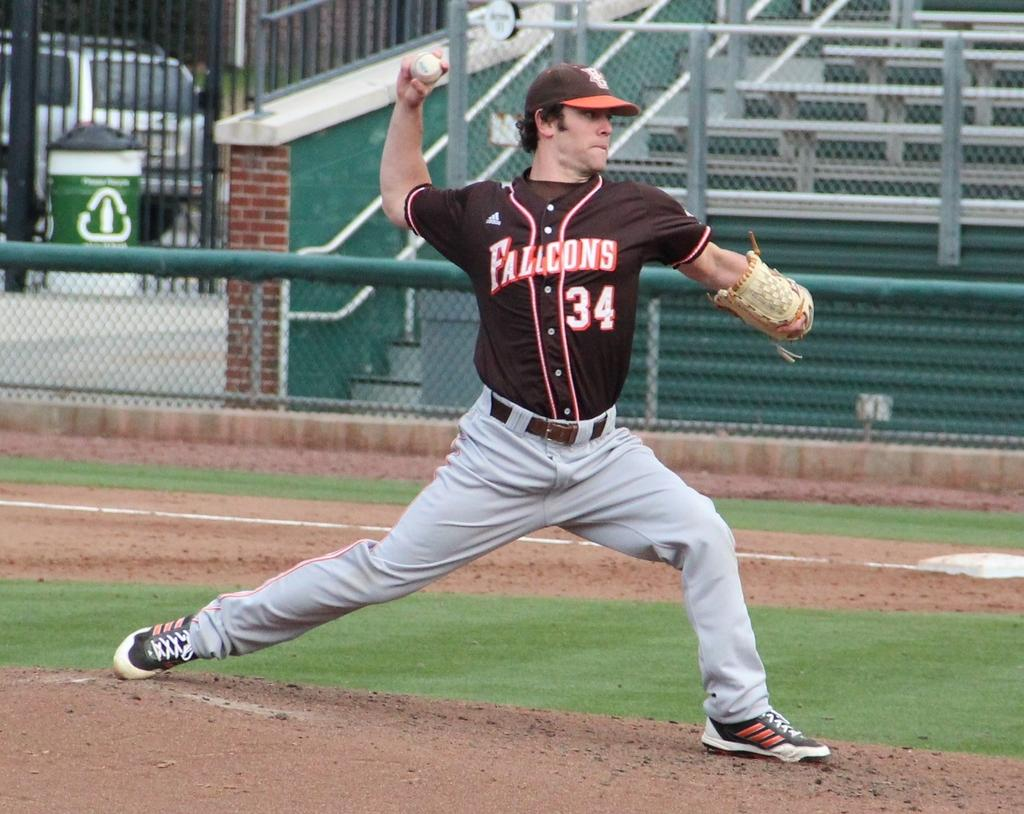Who is present in the image? There is a man in the image. What is the man doing in the image? The man is throwing a ball. What type of surface is at the bottom of the image? There is grass at the bottom of the image. What can be seen in the middle of the image? There is fencing in the middle of the image. What is visible in the background of the image? There is a board and a car in the background of the image. How many snails are crawling on the board in the background of the image? There are no snails visible in the image, so it is not possible to determine how many might be crawling on the board. 